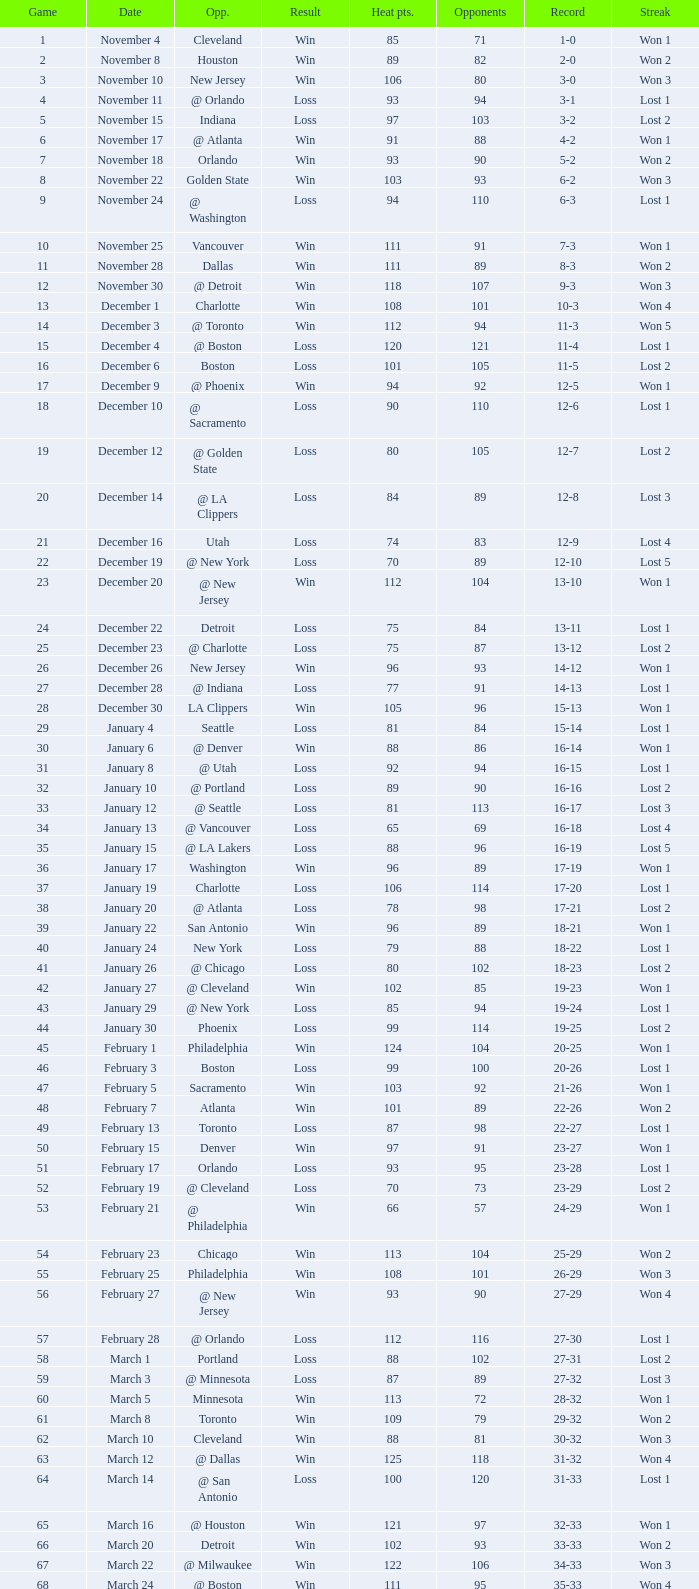What is Streak, when Heat Points is "101", and when Game is "16"? Lost 2. 